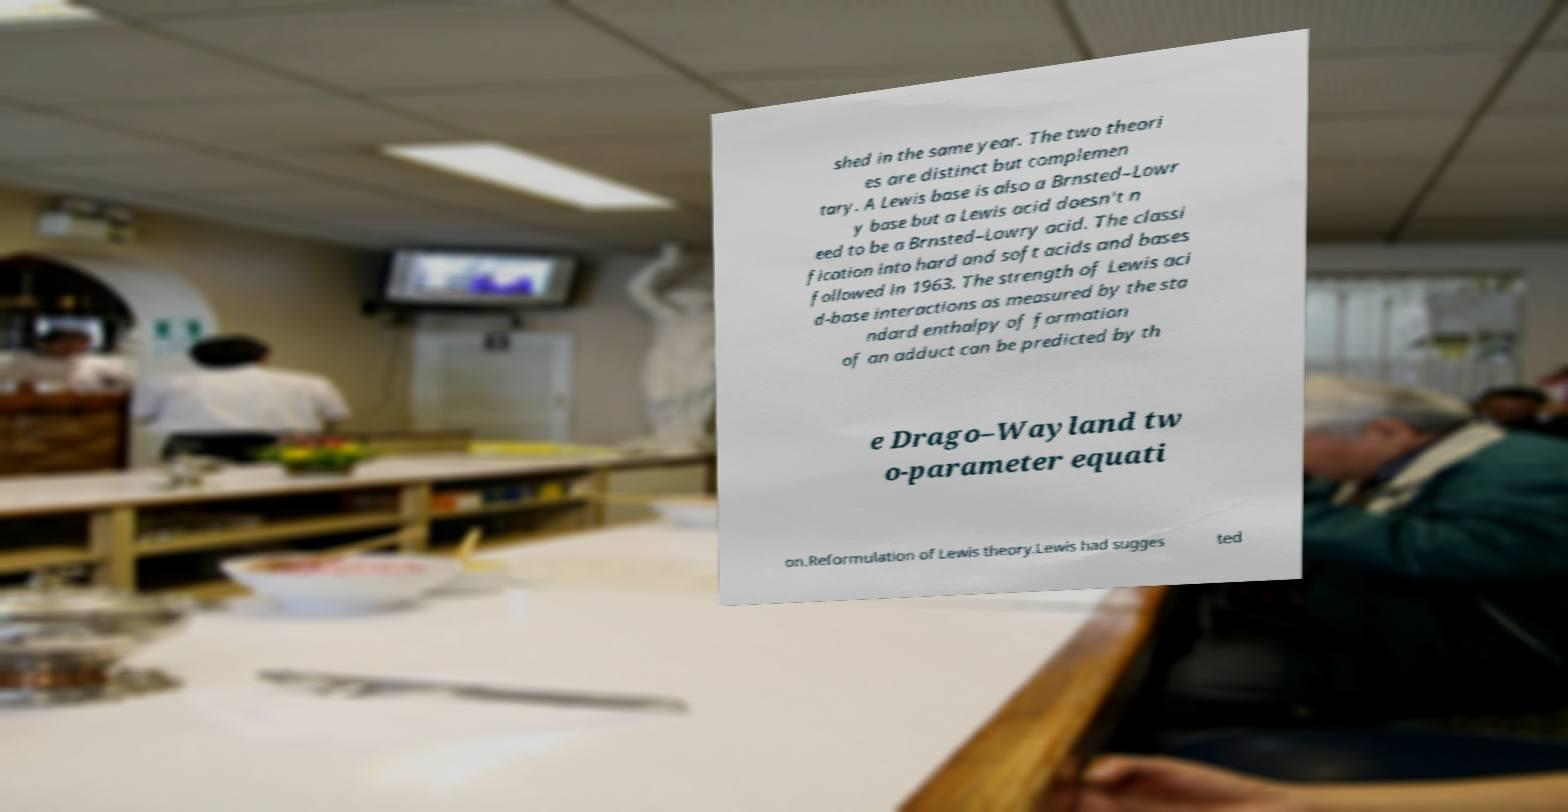Please identify and transcribe the text found in this image. shed in the same year. The two theori es are distinct but complemen tary. A Lewis base is also a Brnsted–Lowr y base but a Lewis acid doesn't n eed to be a Brnsted–Lowry acid. The classi fication into hard and soft acids and bases followed in 1963. The strength of Lewis aci d-base interactions as measured by the sta ndard enthalpy of formation of an adduct can be predicted by th e Drago–Wayland tw o-parameter equati on.Reformulation of Lewis theory.Lewis had sugges ted 